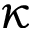<formula> <loc_0><loc_0><loc_500><loc_500>\kappa</formula> 